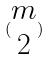<formula> <loc_0><loc_0><loc_500><loc_500>( \begin{matrix} m \\ 2 \end{matrix} )</formula> 